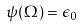Convert formula to latex. <formula><loc_0><loc_0><loc_500><loc_500>\psi ( \Omega ) = \epsilon _ { 0 }</formula> 